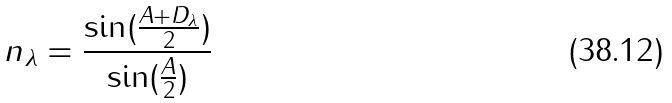Convert formula to latex. <formula><loc_0><loc_0><loc_500><loc_500>n _ { \lambda } = \frac { \sin ( \frac { A + D _ { \lambda } } { 2 } ) } { \sin ( \frac { A } { 2 } ) }</formula> 